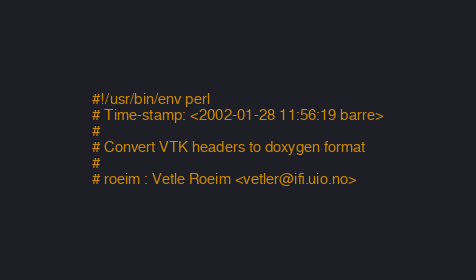Convert code to text. <code><loc_0><loc_0><loc_500><loc_500><_Perl_>#!/usr/bin/env perl
# Time-stamp: <2002-01-28 11:56:19 barre>
#
# Convert VTK headers to doxygen format
#
# roeim : Vetle Roeim <vetler@ifi.uio.no></code> 